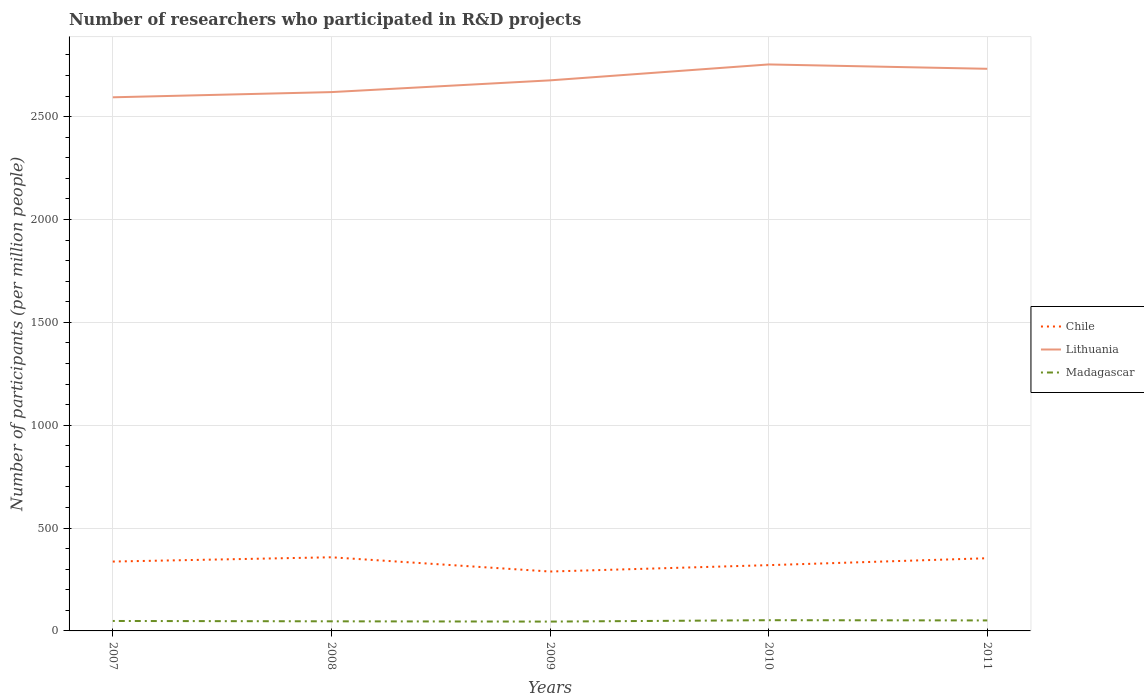How many different coloured lines are there?
Make the answer very short. 3. Does the line corresponding to Lithuania intersect with the line corresponding to Chile?
Provide a succinct answer. No. Across all years, what is the maximum number of researchers who participated in R&D projects in Chile?
Give a very brief answer. 288.71. In which year was the number of researchers who participated in R&D projects in Chile maximum?
Make the answer very short. 2009. What is the total number of researchers who participated in R&D projects in Chile in the graph?
Provide a short and direct response. 4.62. What is the difference between the highest and the second highest number of researchers who participated in R&D projects in Chile?
Make the answer very short. 69.28. What is the difference between the highest and the lowest number of researchers who participated in R&D projects in Chile?
Ensure brevity in your answer.  3. How many lines are there?
Give a very brief answer. 3. How many years are there in the graph?
Keep it short and to the point. 5. What is the title of the graph?
Give a very brief answer. Number of researchers who participated in R&D projects. What is the label or title of the X-axis?
Make the answer very short. Years. What is the label or title of the Y-axis?
Make the answer very short. Number of participants (per million people). What is the Number of participants (per million people) in Chile in 2007?
Offer a very short reply. 337.18. What is the Number of participants (per million people) in Lithuania in 2007?
Keep it short and to the point. 2593.81. What is the Number of participants (per million people) in Madagascar in 2007?
Give a very brief answer. 48.37. What is the Number of participants (per million people) in Chile in 2008?
Your response must be concise. 357.99. What is the Number of participants (per million people) of Lithuania in 2008?
Provide a short and direct response. 2619.11. What is the Number of participants (per million people) of Madagascar in 2008?
Your answer should be compact. 46.67. What is the Number of participants (per million people) in Chile in 2009?
Your response must be concise. 288.71. What is the Number of participants (per million people) of Lithuania in 2009?
Make the answer very short. 2676.18. What is the Number of participants (per million people) of Madagascar in 2009?
Keep it short and to the point. 45.38. What is the Number of participants (per million people) in Chile in 2010?
Your answer should be very brief. 319.72. What is the Number of participants (per million people) of Lithuania in 2010?
Your response must be concise. 2753.59. What is the Number of participants (per million people) of Madagascar in 2010?
Your answer should be compact. 52.14. What is the Number of participants (per million people) in Chile in 2011?
Give a very brief answer. 353.37. What is the Number of participants (per million people) in Lithuania in 2011?
Your answer should be compact. 2732.37. What is the Number of participants (per million people) of Madagascar in 2011?
Offer a very short reply. 51.02. Across all years, what is the maximum Number of participants (per million people) of Chile?
Give a very brief answer. 357.99. Across all years, what is the maximum Number of participants (per million people) in Lithuania?
Offer a very short reply. 2753.59. Across all years, what is the maximum Number of participants (per million people) of Madagascar?
Keep it short and to the point. 52.14. Across all years, what is the minimum Number of participants (per million people) in Chile?
Ensure brevity in your answer.  288.71. Across all years, what is the minimum Number of participants (per million people) in Lithuania?
Your answer should be very brief. 2593.81. Across all years, what is the minimum Number of participants (per million people) of Madagascar?
Make the answer very short. 45.38. What is the total Number of participants (per million people) of Chile in the graph?
Provide a short and direct response. 1656.97. What is the total Number of participants (per million people) in Lithuania in the graph?
Your answer should be very brief. 1.34e+04. What is the total Number of participants (per million people) of Madagascar in the graph?
Give a very brief answer. 243.57. What is the difference between the Number of participants (per million people) of Chile in 2007 and that in 2008?
Give a very brief answer. -20.81. What is the difference between the Number of participants (per million people) in Lithuania in 2007 and that in 2008?
Offer a very short reply. -25.29. What is the difference between the Number of participants (per million people) of Madagascar in 2007 and that in 2008?
Give a very brief answer. 1.7. What is the difference between the Number of participants (per million people) in Chile in 2007 and that in 2009?
Your response must be concise. 48.47. What is the difference between the Number of participants (per million people) of Lithuania in 2007 and that in 2009?
Your response must be concise. -82.36. What is the difference between the Number of participants (per million people) of Madagascar in 2007 and that in 2009?
Ensure brevity in your answer.  3. What is the difference between the Number of participants (per million people) in Chile in 2007 and that in 2010?
Give a very brief answer. 17.47. What is the difference between the Number of participants (per million people) in Lithuania in 2007 and that in 2010?
Offer a very short reply. -159.77. What is the difference between the Number of participants (per million people) of Madagascar in 2007 and that in 2010?
Provide a succinct answer. -3.76. What is the difference between the Number of participants (per million people) of Chile in 2007 and that in 2011?
Offer a terse response. -16.19. What is the difference between the Number of participants (per million people) in Lithuania in 2007 and that in 2011?
Make the answer very short. -138.56. What is the difference between the Number of participants (per million people) in Madagascar in 2007 and that in 2011?
Your answer should be very brief. -2.65. What is the difference between the Number of participants (per million people) of Chile in 2008 and that in 2009?
Make the answer very short. 69.28. What is the difference between the Number of participants (per million people) in Lithuania in 2008 and that in 2009?
Offer a very short reply. -57.07. What is the difference between the Number of participants (per million people) of Madagascar in 2008 and that in 2009?
Your answer should be very brief. 1.3. What is the difference between the Number of participants (per million people) in Chile in 2008 and that in 2010?
Provide a succinct answer. 38.27. What is the difference between the Number of participants (per million people) in Lithuania in 2008 and that in 2010?
Offer a very short reply. -134.48. What is the difference between the Number of participants (per million people) in Madagascar in 2008 and that in 2010?
Make the answer very short. -5.47. What is the difference between the Number of participants (per million people) in Chile in 2008 and that in 2011?
Offer a very short reply. 4.62. What is the difference between the Number of participants (per million people) in Lithuania in 2008 and that in 2011?
Your answer should be compact. -113.27. What is the difference between the Number of participants (per million people) in Madagascar in 2008 and that in 2011?
Your answer should be compact. -4.35. What is the difference between the Number of participants (per million people) in Chile in 2009 and that in 2010?
Offer a terse response. -31.01. What is the difference between the Number of participants (per million people) of Lithuania in 2009 and that in 2010?
Keep it short and to the point. -77.41. What is the difference between the Number of participants (per million people) in Madagascar in 2009 and that in 2010?
Offer a very short reply. -6.76. What is the difference between the Number of participants (per million people) of Chile in 2009 and that in 2011?
Offer a terse response. -64.66. What is the difference between the Number of participants (per million people) in Lithuania in 2009 and that in 2011?
Offer a terse response. -56.19. What is the difference between the Number of participants (per million people) of Madagascar in 2009 and that in 2011?
Your response must be concise. -5.64. What is the difference between the Number of participants (per million people) of Chile in 2010 and that in 2011?
Your answer should be very brief. -33.65. What is the difference between the Number of participants (per million people) of Lithuania in 2010 and that in 2011?
Give a very brief answer. 21.22. What is the difference between the Number of participants (per million people) in Madagascar in 2010 and that in 2011?
Make the answer very short. 1.12. What is the difference between the Number of participants (per million people) in Chile in 2007 and the Number of participants (per million people) in Lithuania in 2008?
Your answer should be compact. -2281.92. What is the difference between the Number of participants (per million people) of Chile in 2007 and the Number of participants (per million people) of Madagascar in 2008?
Your answer should be very brief. 290.51. What is the difference between the Number of participants (per million people) of Lithuania in 2007 and the Number of participants (per million people) of Madagascar in 2008?
Your answer should be very brief. 2547.14. What is the difference between the Number of participants (per million people) in Chile in 2007 and the Number of participants (per million people) in Lithuania in 2009?
Your response must be concise. -2338.99. What is the difference between the Number of participants (per million people) of Chile in 2007 and the Number of participants (per million people) of Madagascar in 2009?
Keep it short and to the point. 291.81. What is the difference between the Number of participants (per million people) in Lithuania in 2007 and the Number of participants (per million people) in Madagascar in 2009?
Make the answer very short. 2548.44. What is the difference between the Number of participants (per million people) of Chile in 2007 and the Number of participants (per million people) of Lithuania in 2010?
Your answer should be very brief. -2416.4. What is the difference between the Number of participants (per million people) of Chile in 2007 and the Number of participants (per million people) of Madagascar in 2010?
Keep it short and to the point. 285.05. What is the difference between the Number of participants (per million people) of Lithuania in 2007 and the Number of participants (per million people) of Madagascar in 2010?
Provide a succinct answer. 2541.68. What is the difference between the Number of participants (per million people) in Chile in 2007 and the Number of participants (per million people) in Lithuania in 2011?
Ensure brevity in your answer.  -2395.19. What is the difference between the Number of participants (per million people) in Chile in 2007 and the Number of participants (per million people) in Madagascar in 2011?
Keep it short and to the point. 286.17. What is the difference between the Number of participants (per million people) of Lithuania in 2007 and the Number of participants (per million people) of Madagascar in 2011?
Offer a terse response. 2542.8. What is the difference between the Number of participants (per million people) of Chile in 2008 and the Number of participants (per million people) of Lithuania in 2009?
Give a very brief answer. -2318.19. What is the difference between the Number of participants (per million people) in Chile in 2008 and the Number of participants (per million people) in Madagascar in 2009?
Offer a very short reply. 312.61. What is the difference between the Number of participants (per million people) in Lithuania in 2008 and the Number of participants (per million people) in Madagascar in 2009?
Provide a succinct answer. 2573.73. What is the difference between the Number of participants (per million people) of Chile in 2008 and the Number of participants (per million people) of Lithuania in 2010?
Offer a terse response. -2395.6. What is the difference between the Number of participants (per million people) of Chile in 2008 and the Number of participants (per million people) of Madagascar in 2010?
Your answer should be very brief. 305.85. What is the difference between the Number of participants (per million people) of Lithuania in 2008 and the Number of participants (per million people) of Madagascar in 2010?
Give a very brief answer. 2566.97. What is the difference between the Number of participants (per million people) in Chile in 2008 and the Number of participants (per million people) in Lithuania in 2011?
Give a very brief answer. -2374.38. What is the difference between the Number of participants (per million people) in Chile in 2008 and the Number of participants (per million people) in Madagascar in 2011?
Your answer should be compact. 306.97. What is the difference between the Number of participants (per million people) of Lithuania in 2008 and the Number of participants (per million people) of Madagascar in 2011?
Your answer should be very brief. 2568.09. What is the difference between the Number of participants (per million people) of Chile in 2009 and the Number of participants (per million people) of Lithuania in 2010?
Make the answer very short. -2464.88. What is the difference between the Number of participants (per million people) of Chile in 2009 and the Number of participants (per million people) of Madagascar in 2010?
Your response must be concise. 236.58. What is the difference between the Number of participants (per million people) in Lithuania in 2009 and the Number of participants (per million people) in Madagascar in 2010?
Your answer should be very brief. 2624.04. What is the difference between the Number of participants (per million people) in Chile in 2009 and the Number of participants (per million people) in Lithuania in 2011?
Make the answer very short. -2443.66. What is the difference between the Number of participants (per million people) in Chile in 2009 and the Number of participants (per million people) in Madagascar in 2011?
Your response must be concise. 237.69. What is the difference between the Number of participants (per million people) of Lithuania in 2009 and the Number of participants (per million people) of Madagascar in 2011?
Offer a terse response. 2625.16. What is the difference between the Number of participants (per million people) of Chile in 2010 and the Number of participants (per million people) of Lithuania in 2011?
Give a very brief answer. -2412.65. What is the difference between the Number of participants (per million people) in Chile in 2010 and the Number of participants (per million people) in Madagascar in 2011?
Your answer should be very brief. 268.7. What is the difference between the Number of participants (per million people) in Lithuania in 2010 and the Number of participants (per million people) in Madagascar in 2011?
Offer a very short reply. 2702.57. What is the average Number of participants (per million people) of Chile per year?
Offer a terse response. 331.39. What is the average Number of participants (per million people) in Lithuania per year?
Keep it short and to the point. 2675.01. What is the average Number of participants (per million people) in Madagascar per year?
Keep it short and to the point. 48.71. In the year 2007, what is the difference between the Number of participants (per million people) in Chile and Number of participants (per million people) in Lithuania?
Offer a very short reply. -2256.63. In the year 2007, what is the difference between the Number of participants (per million people) in Chile and Number of participants (per million people) in Madagascar?
Ensure brevity in your answer.  288.81. In the year 2007, what is the difference between the Number of participants (per million people) in Lithuania and Number of participants (per million people) in Madagascar?
Your answer should be compact. 2545.44. In the year 2008, what is the difference between the Number of participants (per million people) in Chile and Number of participants (per million people) in Lithuania?
Ensure brevity in your answer.  -2261.12. In the year 2008, what is the difference between the Number of participants (per million people) in Chile and Number of participants (per million people) in Madagascar?
Provide a short and direct response. 311.32. In the year 2008, what is the difference between the Number of participants (per million people) of Lithuania and Number of participants (per million people) of Madagascar?
Provide a succinct answer. 2572.43. In the year 2009, what is the difference between the Number of participants (per million people) of Chile and Number of participants (per million people) of Lithuania?
Your answer should be compact. -2387.47. In the year 2009, what is the difference between the Number of participants (per million people) in Chile and Number of participants (per million people) in Madagascar?
Ensure brevity in your answer.  243.34. In the year 2009, what is the difference between the Number of participants (per million people) of Lithuania and Number of participants (per million people) of Madagascar?
Offer a terse response. 2630.8. In the year 2010, what is the difference between the Number of participants (per million people) of Chile and Number of participants (per million people) of Lithuania?
Your answer should be very brief. -2433.87. In the year 2010, what is the difference between the Number of participants (per million people) of Chile and Number of participants (per million people) of Madagascar?
Offer a very short reply. 267.58. In the year 2010, what is the difference between the Number of participants (per million people) of Lithuania and Number of participants (per million people) of Madagascar?
Your answer should be compact. 2701.45. In the year 2011, what is the difference between the Number of participants (per million people) of Chile and Number of participants (per million people) of Lithuania?
Provide a short and direct response. -2379. In the year 2011, what is the difference between the Number of participants (per million people) in Chile and Number of participants (per million people) in Madagascar?
Give a very brief answer. 302.35. In the year 2011, what is the difference between the Number of participants (per million people) of Lithuania and Number of participants (per million people) of Madagascar?
Your answer should be compact. 2681.35. What is the ratio of the Number of participants (per million people) in Chile in 2007 to that in 2008?
Provide a short and direct response. 0.94. What is the ratio of the Number of participants (per million people) of Lithuania in 2007 to that in 2008?
Your answer should be very brief. 0.99. What is the ratio of the Number of participants (per million people) in Madagascar in 2007 to that in 2008?
Provide a succinct answer. 1.04. What is the ratio of the Number of participants (per million people) of Chile in 2007 to that in 2009?
Offer a very short reply. 1.17. What is the ratio of the Number of participants (per million people) of Lithuania in 2007 to that in 2009?
Ensure brevity in your answer.  0.97. What is the ratio of the Number of participants (per million people) of Madagascar in 2007 to that in 2009?
Make the answer very short. 1.07. What is the ratio of the Number of participants (per million people) in Chile in 2007 to that in 2010?
Provide a succinct answer. 1.05. What is the ratio of the Number of participants (per million people) in Lithuania in 2007 to that in 2010?
Offer a terse response. 0.94. What is the ratio of the Number of participants (per million people) in Madagascar in 2007 to that in 2010?
Provide a succinct answer. 0.93. What is the ratio of the Number of participants (per million people) of Chile in 2007 to that in 2011?
Offer a terse response. 0.95. What is the ratio of the Number of participants (per million people) in Lithuania in 2007 to that in 2011?
Provide a succinct answer. 0.95. What is the ratio of the Number of participants (per million people) in Madagascar in 2007 to that in 2011?
Your answer should be very brief. 0.95. What is the ratio of the Number of participants (per million people) in Chile in 2008 to that in 2009?
Provide a short and direct response. 1.24. What is the ratio of the Number of participants (per million people) of Lithuania in 2008 to that in 2009?
Your answer should be compact. 0.98. What is the ratio of the Number of participants (per million people) in Madagascar in 2008 to that in 2009?
Ensure brevity in your answer.  1.03. What is the ratio of the Number of participants (per million people) in Chile in 2008 to that in 2010?
Provide a short and direct response. 1.12. What is the ratio of the Number of participants (per million people) in Lithuania in 2008 to that in 2010?
Your answer should be compact. 0.95. What is the ratio of the Number of participants (per million people) in Madagascar in 2008 to that in 2010?
Provide a short and direct response. 0.9. What is the ratio of the Number of participants (per million people) of Chile in 2008 to that in 2011?
Your response must be concise. 1.01. What is the ratio of the Number of participants (per million people) in Lithuania in 2008 to that in 2011?
Provide a short and direct response. 0.96. What is the ratio of the Number of participants (per million people) of Madagascar in 2008 to that in 2011?
Give a very brief answer. 0.91. What is the ratio of the Number of participants (per million people) in Chile in 2009 to that in 2010?
Keep it short and to the point. 0.9. What is the ratio of the Number of participants (per million people) of Lithuania in 2009 to that in 2010?
Your answer should be very brief. 0.97. What is the ratio of the Number of participants (per million people) of Madagascar in 2009 to that in 2010?
Offer a very short reply. 0.87. What is the ratio of the Number of participants (per million people) of Chile in 2009 to that in 2011?
Keep it short and to the point. 0.82. What is the ratio of the Number of participants (per million people) of Lithuania in 2009 to that in 2011?
Keep it short and to the point. 0.98. What is the ratio of the Number of participants (per million people) in Madagascar in 2009 to that in 2011?
Keep it short and to the point. 0.89. What is the ratio of the Number of participants (per million people) in Chile in 2010 to that in 2011?
Give a very brief answer. 0.9. What is the ratio of the Number of participants (per million people) in Lithuania in 2010 to that in 2011?
Provide a short and direct response. 1.01. What is the ratio of the Number of participants (per million people) of Madagascar in 2010 to that in 2011?
Offer a very short reply. 1.02. What is the difference between the highest and the second highest Number of participants (per million people) in Chile?
Offer a very short reply. 4.62. What is the difference between the highest and the second highest Number of participants (per million people) in Lithuania?
Offer a terse response. 21.22. What is the difference between the highest and the second highest Number of participants (per million people) in Madagascar?
Keep it short and to the point. 1.12. What is the difference between the highest and the lowest Number of participants (per million people) of Chile?
Your response must be concise. 69.28. What is the difference between the highest and the lowest Number of participants (per million people) in Lithuania?
Give a very brief answer. 159.77. What is the difference between the highest and the lowest Number of participants (per million people) in Madagascar?
Keep it short and to the point. 6.76. 